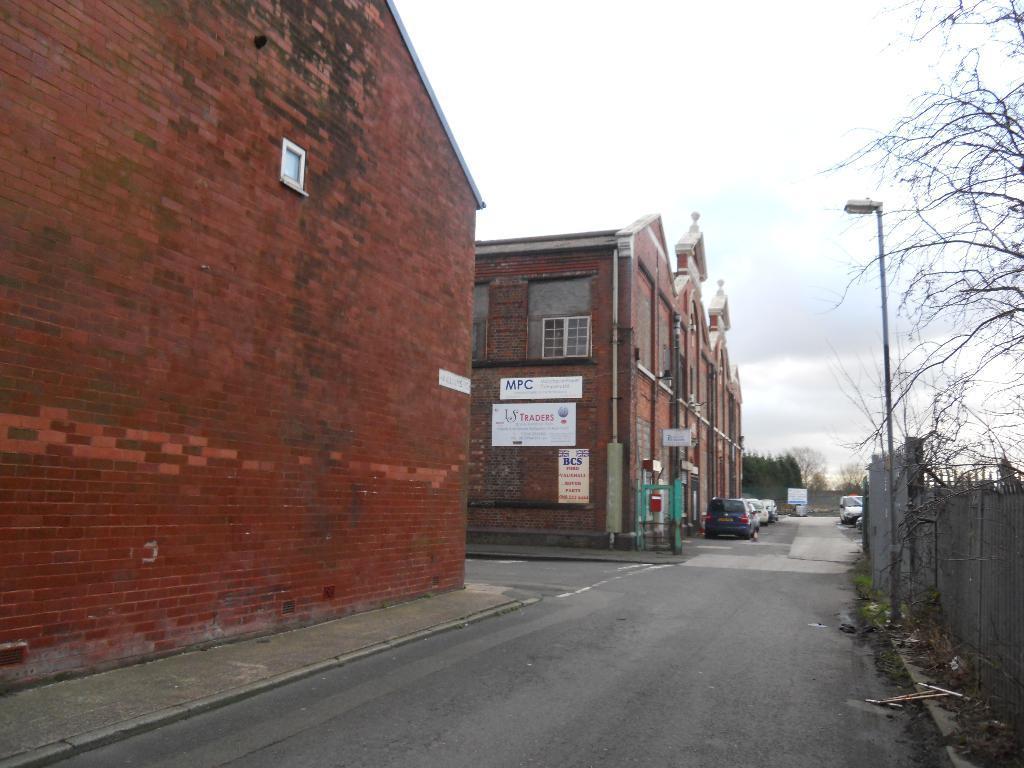How would you summarize this image in a sentence or two? In this picture I can see the road. I can see the vehicles in the parking space. I can see trees. I can see light pole. I can see the buildings.. I can see clouds in the sky. 